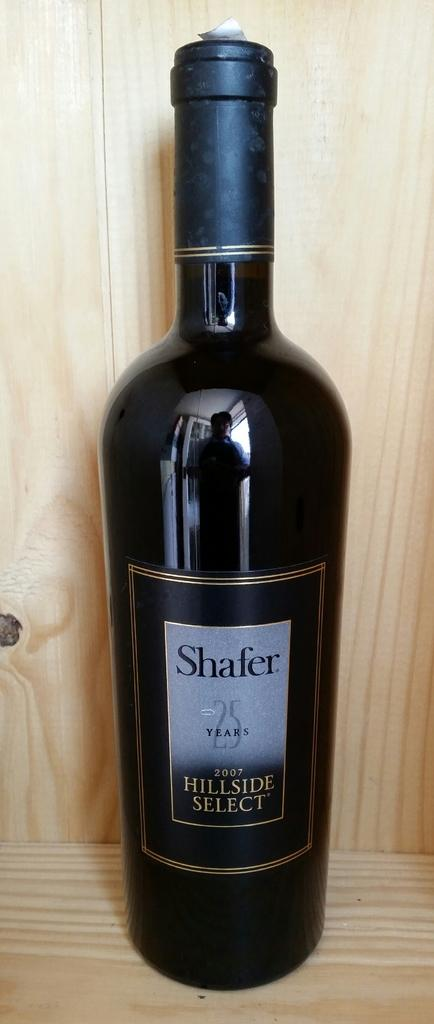<image>
Relay a brief, clear account of the picture shown. A bottle of Shafer Hillside Select wine sits in a wooden cabinet. 